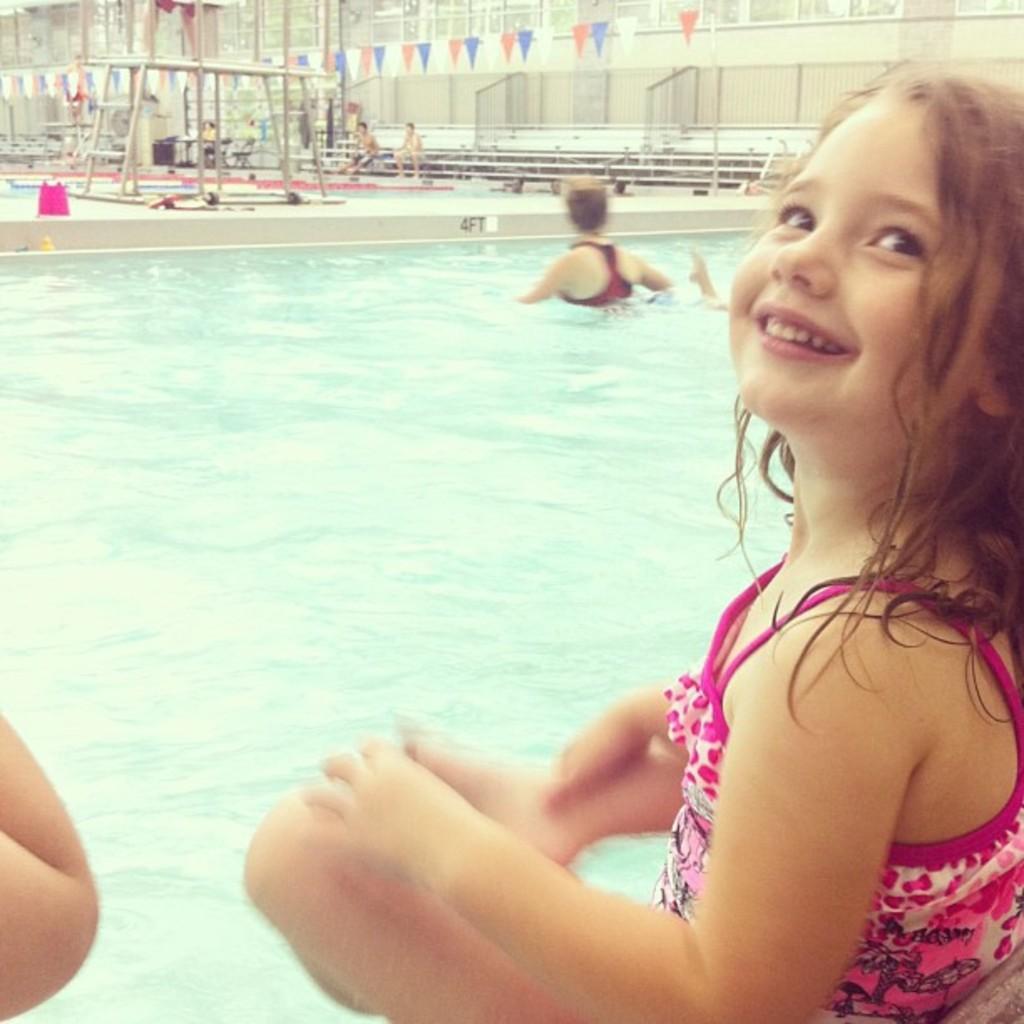In one or two sentences, can you explain what this image depicts? In the image on the right side we can see one girl sitting and she is smiling,which we can see on her face. On the left side,we can see one human hand. In the background there is a building,wall,staircase,fence,garland,pink color bag,ladder,table,swimming pool,chairs,poles and few people were sitting. In the middle of the image,we can see one person in the water. 